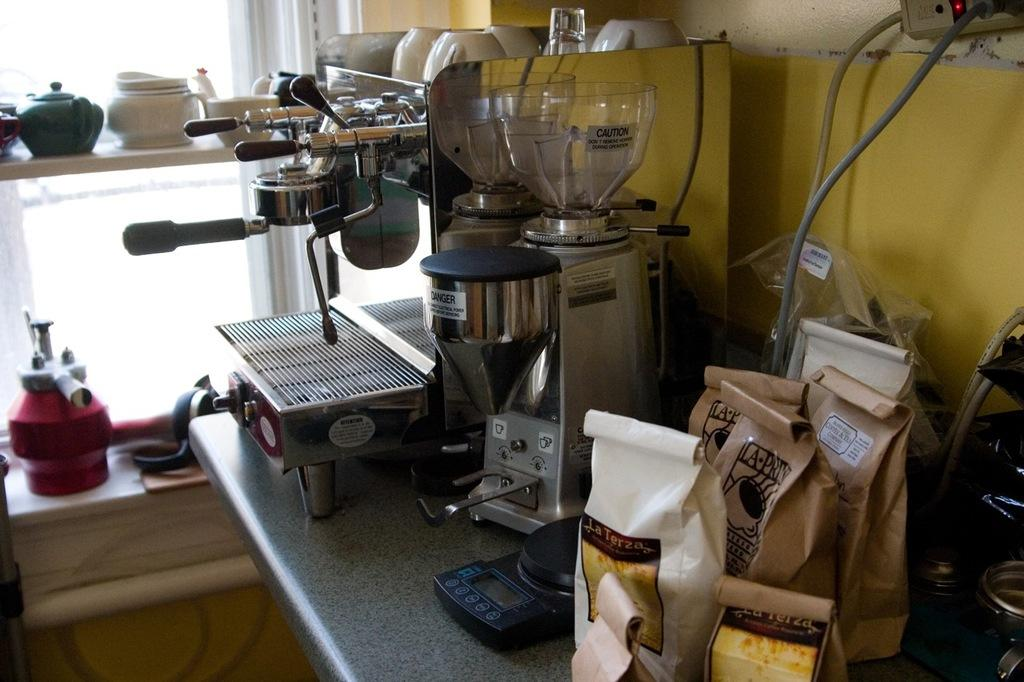<image>
Describe the image concisely. Mixing machines in a bakery with a caution label on the clear bowl 